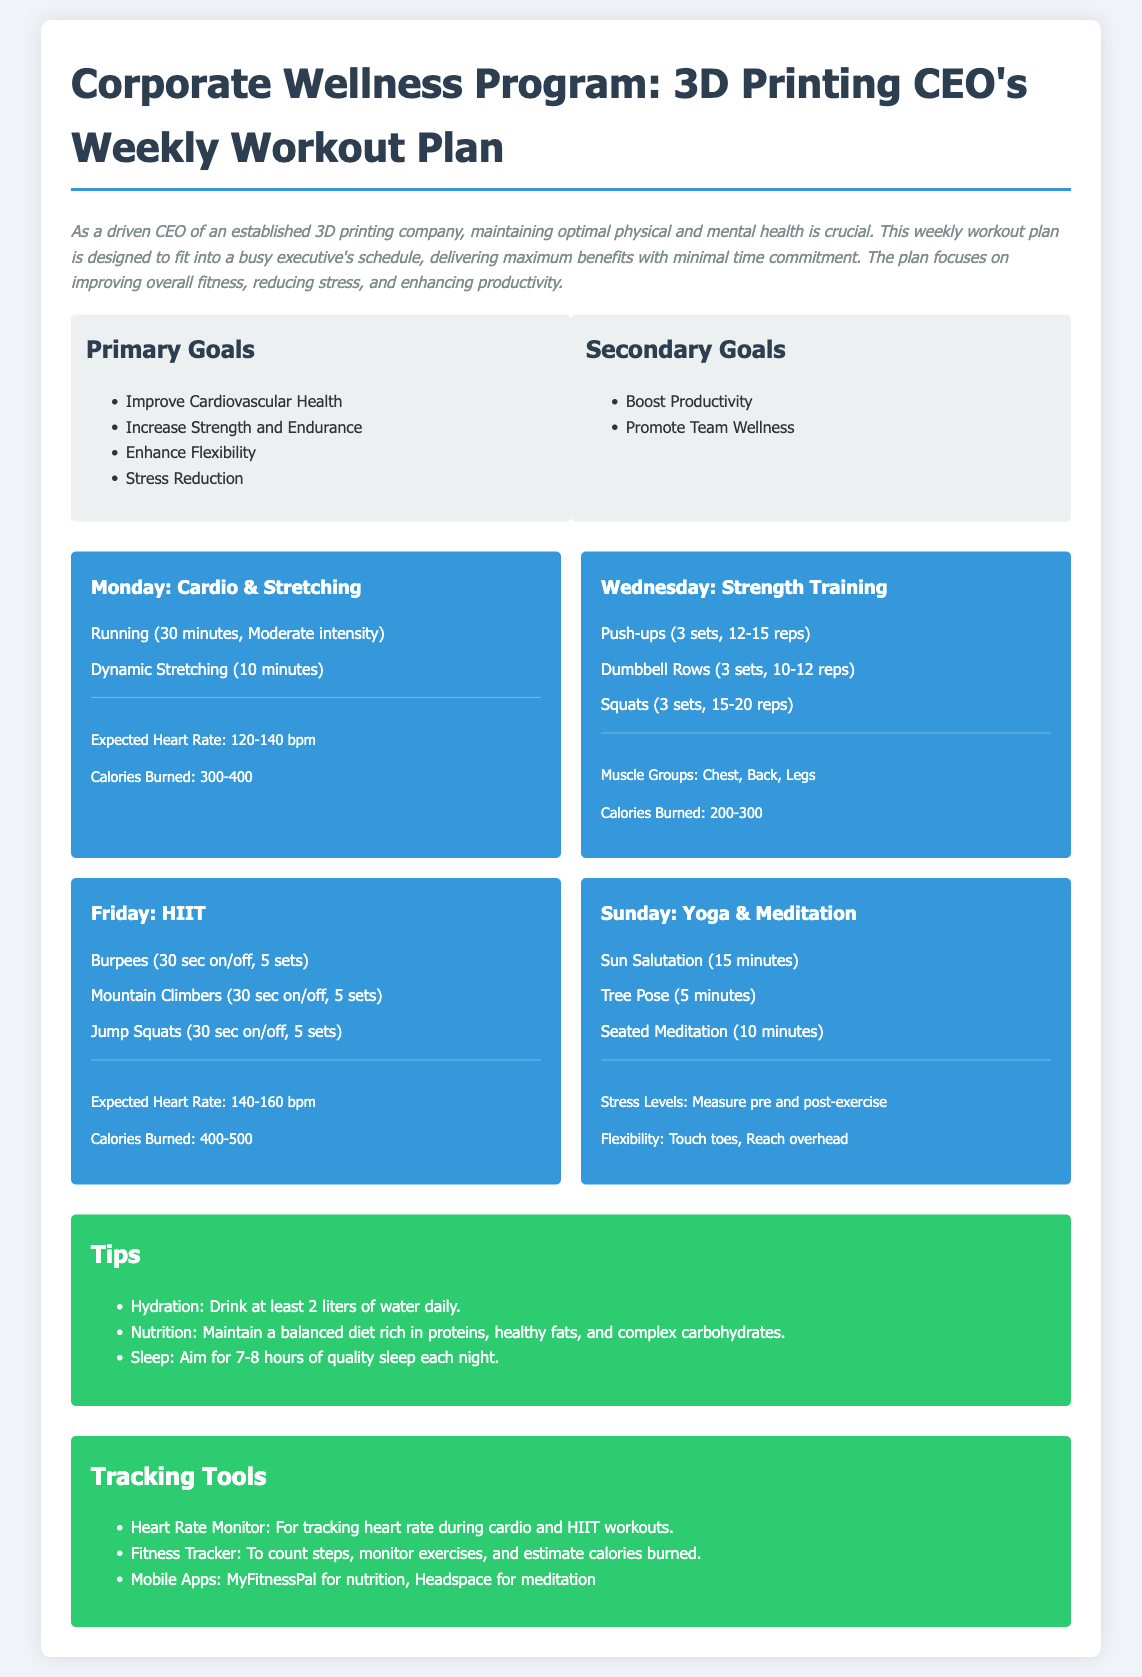What are the primary goals of the workout plan? The primary goals are listed in the document under the "Primary Goals" section, which includes improving cardiovascular health, increasing strength and endurance, enhancing flexibility, and stress reduction.
Answer: Improve Cardiovascular Health, Increase Strength and Endurance, Enhance Flexibility, Stress Reduction What is the duration of the cardio workout on Monday? The duration for running on Monday is specifically stated in the workout plan.
Answer: 30 minutes How many sets of push-ups are included in the Wednesday workout? The document specifies the number of sets for push-ups in the Wednesday workout under the "Strength Training" section.
Answer: 3 sets What is the expected heart rate during the HIIT session on Friday? The expected heart rate for Friday's HIIT workout is mentioned in the metrics section.
Answer: 140-160 bpm Which exercise is included in the Sunday session for meditation? The exercises for Sunday are listed, with one being specifically for meditation as per the workout plan.
Answer: Seated Meditation What is one secondary goal of the program? Secondary goals are mentioned in the document, and one is to boost productivity.
Answer: Boost Productivity How many calories are expected to be burned during the Wednesday strength training session? The expected calories burned for the Wednesday workout are detailed in the document.
Answer: 200-300 What type of exercise is emphasized on Monday? The workout plan for Monday focuses on a specific type of exercise which is outlined in the section.
Answer: Cardio & Stretching 